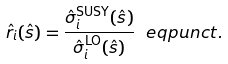<formula> <loc_0><loc_0><loc_500><loc_500>\hat { r } _ { i } ( \hat { s } ) = \frac { \hat { \sigma } _ { i } ^ { \text {SUSY} } ( \hat { s } ) } { \hat { \sigma } _ { i } ^ { \text {LO} } ( \hat { s } ) } \ e q p u n c t .</formula> 